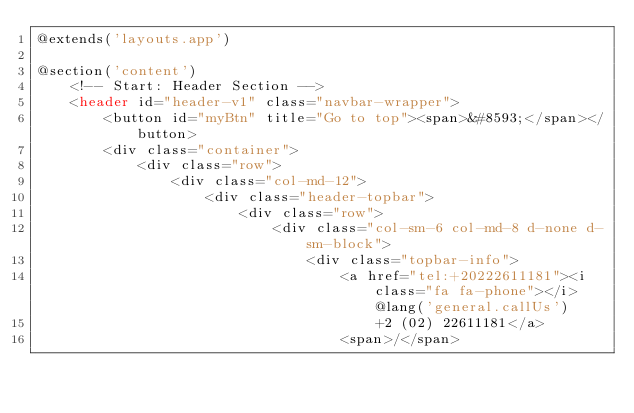<code> <loc_0><loc_0><loc_500><loc_500><_PHP_>@extends('layouts.app')

@section('content')
    <!-- Start: Header Section -->
    <header id="header-v1" class="navbar-wrapper">
        <button id="myBtn" title="Go to top"><span>&#8593;</span></button>
        <div class="container">
            <div class="row">
                <div class="col-md-12">
                    <div class="header-topbar">
                        <div class="row">
                            <div class="col-sm-6 col-md-8 d-none d-sm-block">
                                <div class="topbar-info">
                                    <a href="tel:+20222611181"><i class="fa fa-phone"></i>@lang('general.callUs')
                                        +2 (02) 22611181</a>
                                    <span>/</span></code> 